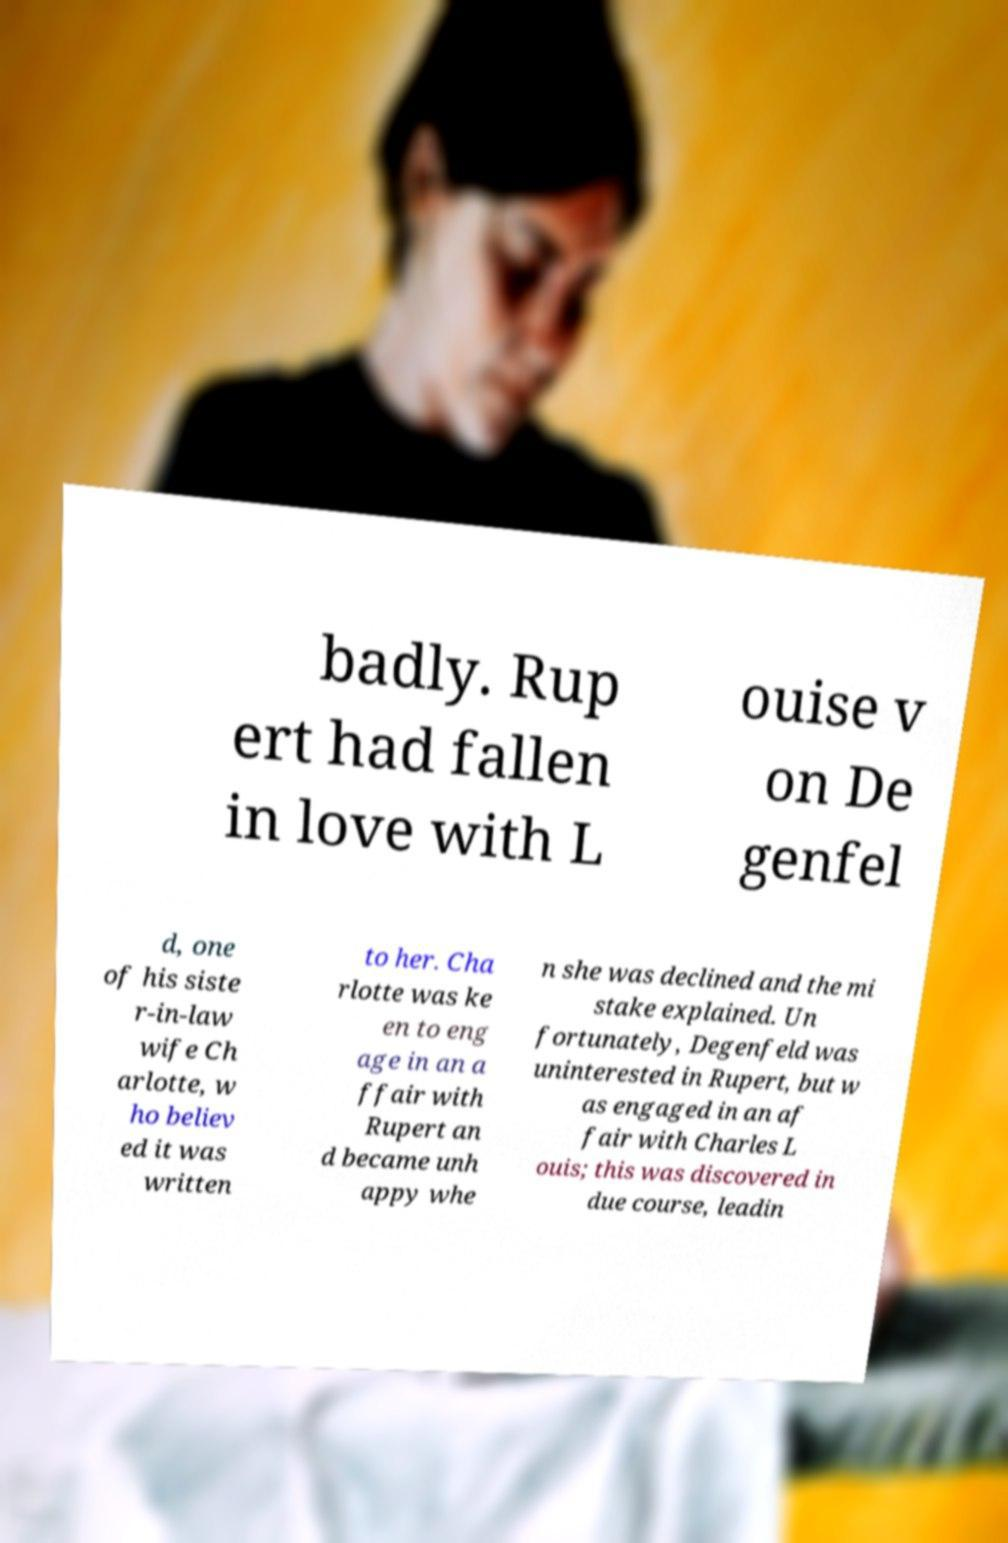Could you extract and type out the text from this image? badly. Rup ert had fallen in love with L ouise v on De genfel d, one of his siste r-in-law wife Ch arlotte, w ho believ ed it was written to her. Cha rlotte was ke en to eng age in an a ffair with Rupert an d became unh appy whe n she was declined and the mi stake explained. Un fortunately, Degenfeld was uninterested in Rupert, but w as engaged in an af fair with Charles L ouis; this was discovered in due course, leadin 